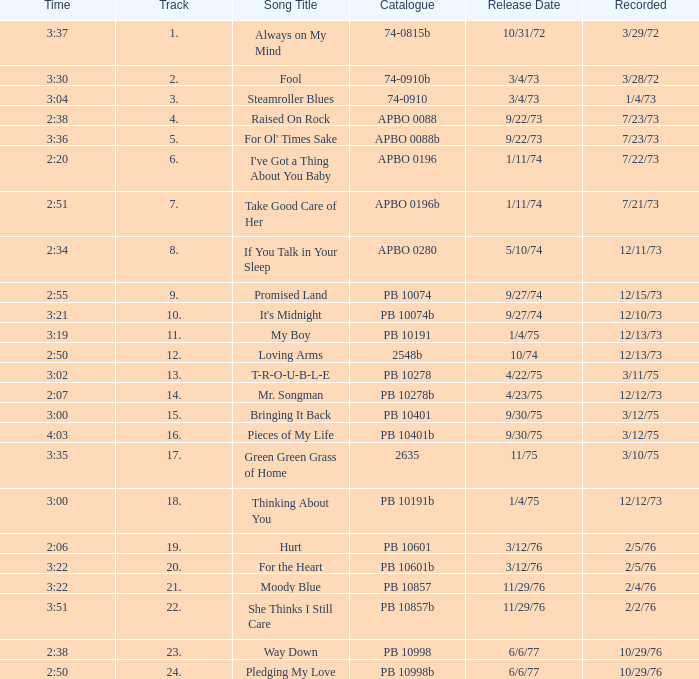Tell me the release date record on 10/29/76 and a time on 2:50 6/6/77. 